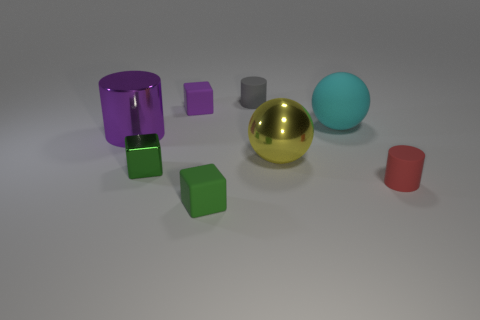There is a small green object to the left of the tiny rubber block that is behind the big ball behind the shiny cylinder; what shape is it?
Offer a very short reply. Cube. There is a matte cylinder behind the big yellow sphere; does it have the same color as the tiny cylinder that is in front of the purple cylinder?
Make the answer very short. No. Is the number of red cylinders that are in front of the red matte thing less than the number of purple shiny things that are on the right side of the cyan matte sphere?
Make the answer very short. No. Is there anything else that is the same shape as the big purple thing?
Give a very brief answer. Yes. The other tiny rubber thing that is the same shape as the small red object is what color?
Offer a terse response. Gray. Do the small purple rubber thing and the large yellow object left of the cyan matte sphere have the same shape?
Offer a terse response. No. What number of things are matte cubes that are in front of the purple matte block or cylinders to the right of the large purple object?
Ensure brevity in your answer.  3. What material is the cyan object?
Keep it short and to the point. Rubber. What number of other objects are there of the same size as the purple rubber block?
Your answer should be very brief. 4. There is a block that is on the right side of the purple rubber thing; what size is it?
Give a very brief answer. Small. 